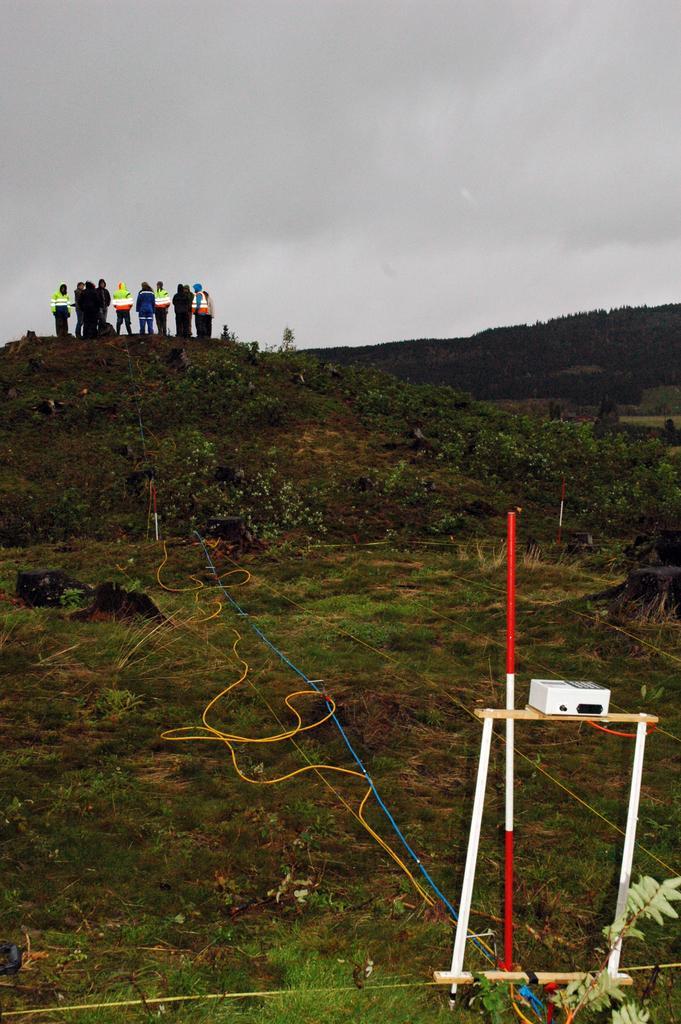Describe this image in one or two sentences. In this image we can see a persons on the hill. At the bottom right corner we can see projector and a pole. In the background there is a sky. 